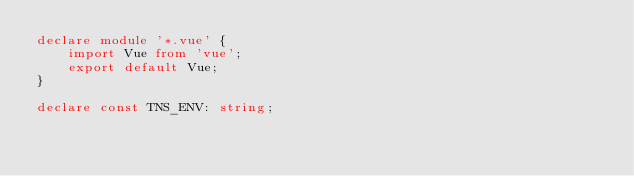<code> <loc_0><loc_0><loc_500><loc_500><_TypeScript_>declare module '*.vue' {
    import Vue from 'vue';
    export default Vue;
}

declare const TNS_ENV: string;</code> 